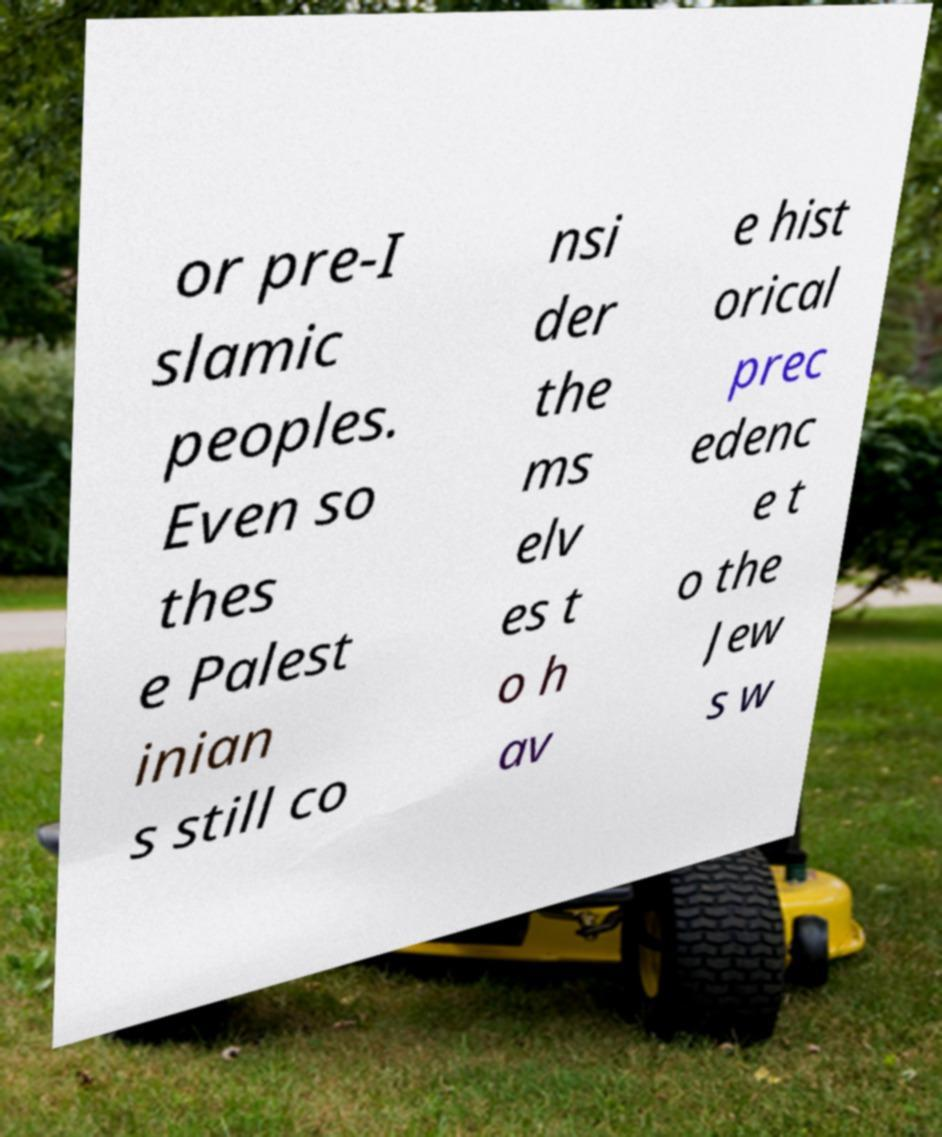Could you assist in decoding the text presented in this image and type it out clearly? or pre-I slamic peoples. Even so thes e Palest inian s still co nsi der the ms elv es t o h av e hist orical prec edenc e t o the Jew s w 